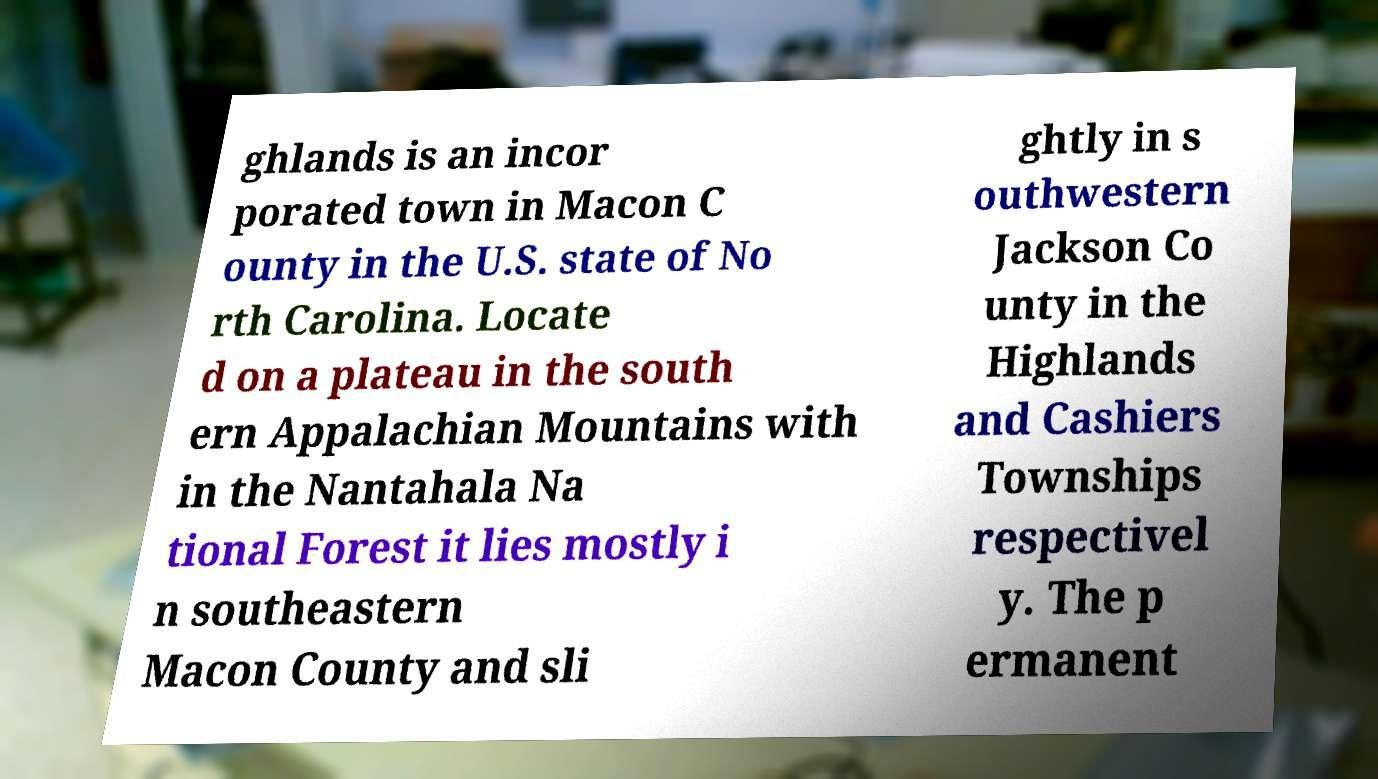Can you read and provide the text displayed in the image?This photo seems to have some interesting text. Can you extract and type it out for me? ghlands is an incor porated town in Macon C ounty in the U.S. state of No rth Carolina. Locate d on a plateau in the south ern Appalachian Mountains with in the Nantahala Na tional Forest it lies mostly i n southeastern Macon County and sli ghtly in s outhwestern Jackson Co unty in the Highlands and Cashiers Townships respectivel y. The p ermanent 